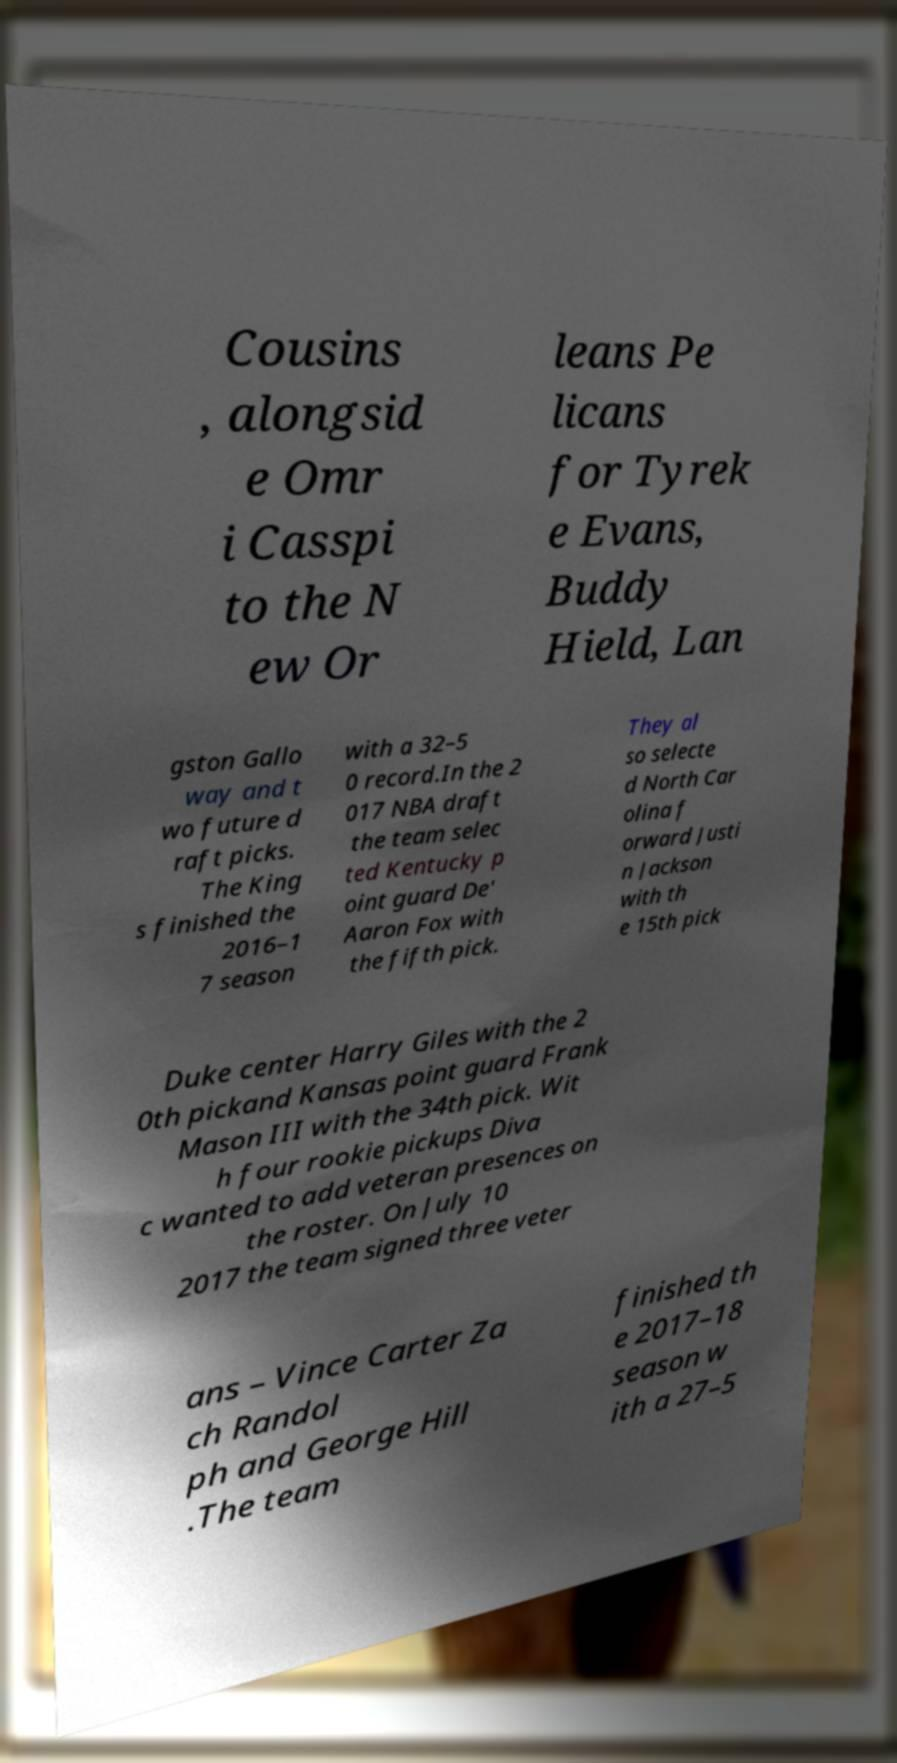What messages or text are displayed in this image? I need them in a readable, typed format. Cousins , alongsid e Omr i Casspi to the N ew Or leans Pe licans for Tyrek e Evans, Buddy Hield, Lan gston Gallo way and t wo future d raft picks. The King s finished the 2016–1 7 season with a 32–5 0 record.In the 2 017 NBA draft the team selec ted Kentucky p oint guard De' Aaron Fox with the fifth pick. They al so selecte d North Car olina f orward Justi n Jackson with th e 15th pick Duke center Harry Giles with the 2 0th pickand Kansas point guard Frank Mason III with the 34th pick. Wit h four rookie pickups Diva c wanted to add veteran presences on the roster. On July 10 2017 the team signed three veter ans – Vince Carter Za ch Randol ph and George Hill .The team finished th e 2017–18 season w ith a 27–5 